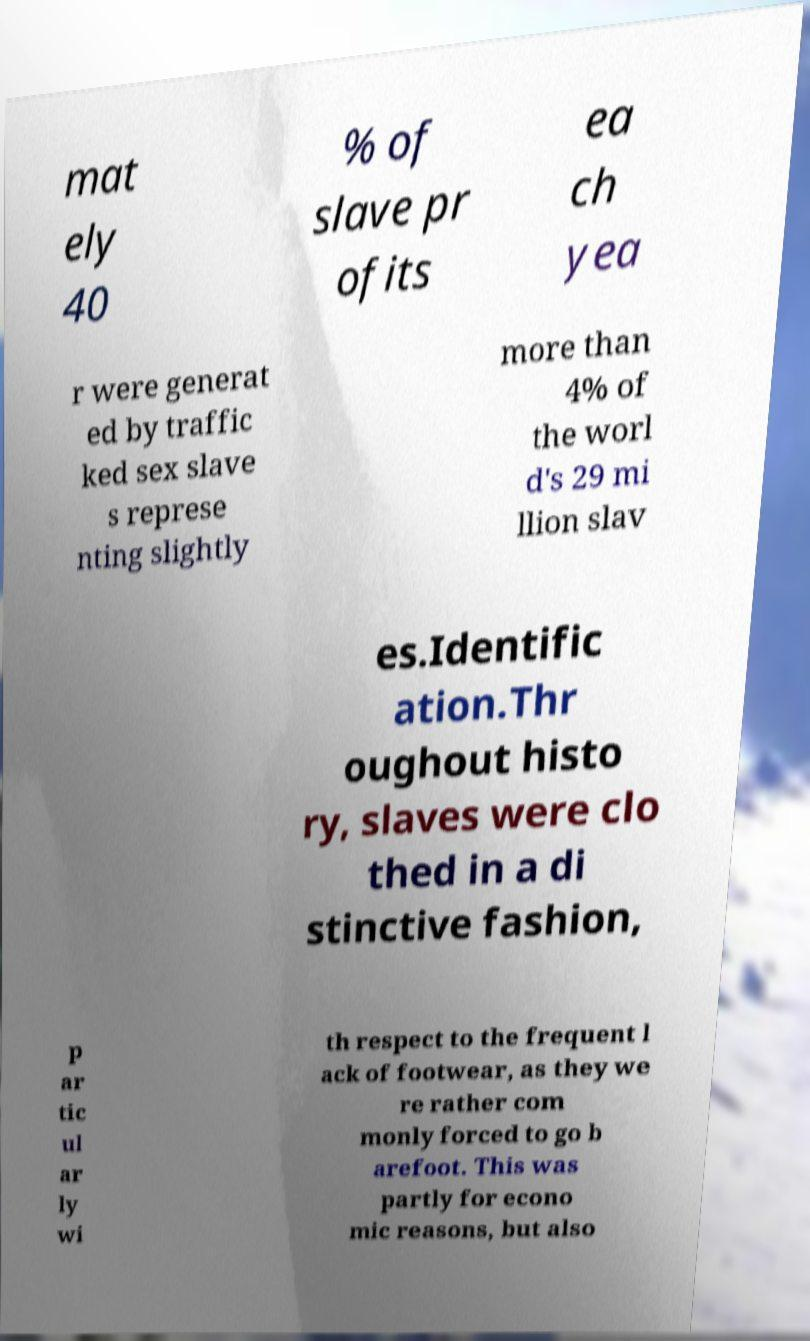Please identify and transcribe the text found in this image. mat ely 40 % of slave pr ofits ea ch yea r were generat ed by traffic ked sex slave s represe nting slightly more than 4% of the worl d's 29 mi llion slav es.Identific ation.Thr oughout histo ry, slaves were clo thed in a di stinctive fashion, p ar tic ul ar ly wi th respect to the frequent l ack of footwear, as they we re rather com monly forced to go b arefoot. This was partly for econo mic reasons, but also 